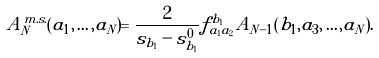Convert formula to latex. <formula><loc_0><loc_0><loc_500><loc_500>A _ { N } ^ { m . s . } ( a _ { 1 } , \dots , a _ { N } ) = \frac { 2 } { s _ { b _ { 1 } } - s ^ { 0 } _ { b _ { 1 } } } f _ { a _ { 1 } a _ { 2 } } ^ { b _ { 1 } } A _ { N - 1 } ( b _ { 1 } , a _ { 3 } , \dots , a _ { N } ) .</formula> 